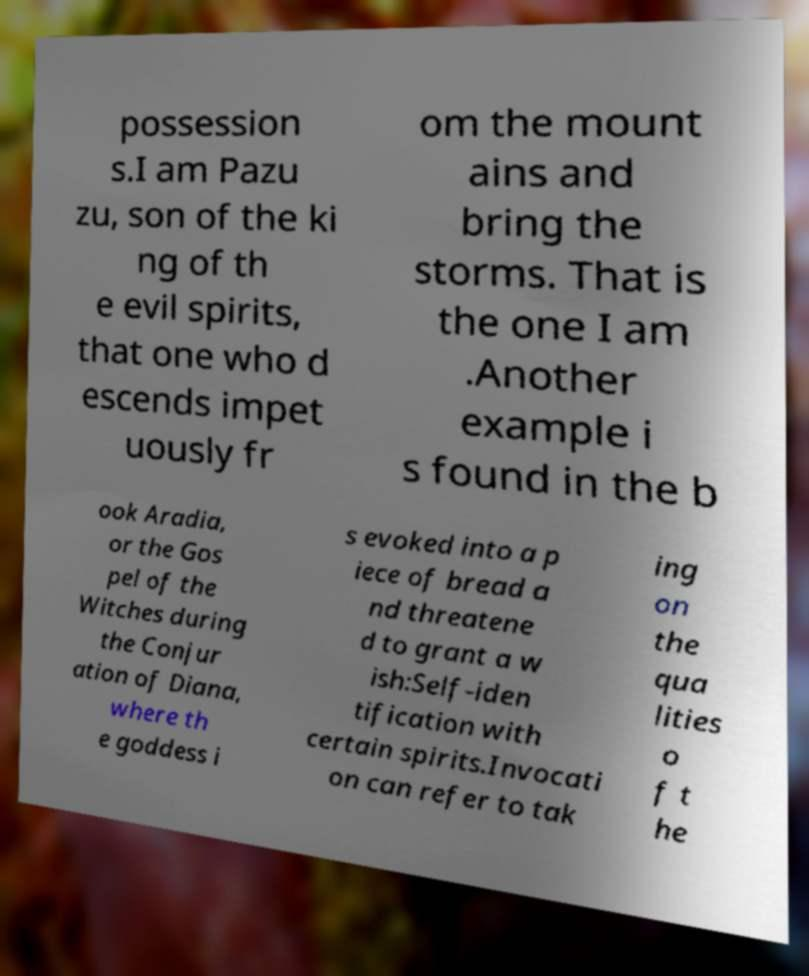Could you assist in decoding the text presented in this image and type it out clearly? possession s.I am Pazu zu, son of the ki ng of th e evil spirits, that one who d escends impet uously fr om the mount ains and bring the storms. That is the one I am .Another example i s found in the b ook Aradia, or the Gos pel of the Witches during the Conjur ation of Diana, where th e goddess i s evoked into a p iece of bread a nd threatene d to grant a w ish:Self-iden tification with certain spirits.Invocati on can refer to tak ing on the qua lities o f t he 